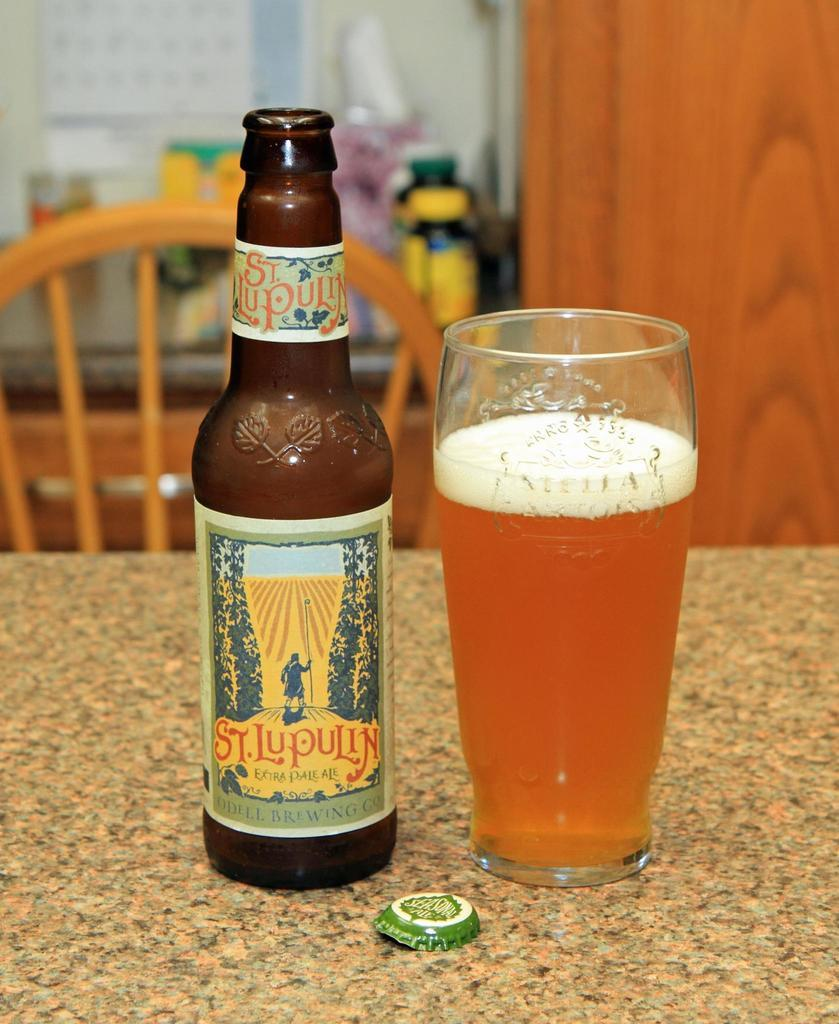What is on the table in the image? There is a bottle and a glass on a table in the image. Where is the table located in the image? The table is in the foreground area of the image. What can be seen in the background of the image? There is a chair and other objects in the background of the image. What type of rod does your uncle use for fishing in the image? There is no uncle or fishing rod present in the image. How does the growth of the plant in the image affect the size of the glass? There is no plant present in the image, so its growth cannot affect the size of the glass. 